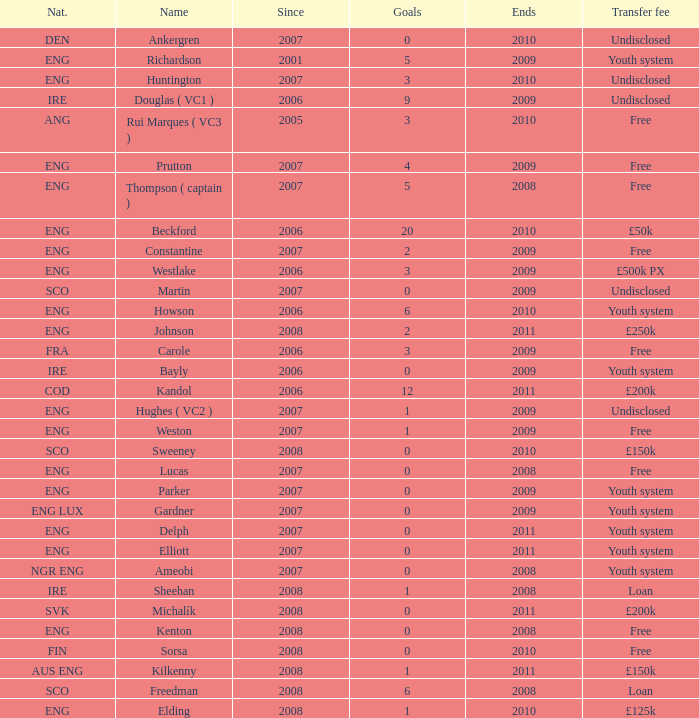Name the average ends for weston 2009.0. 